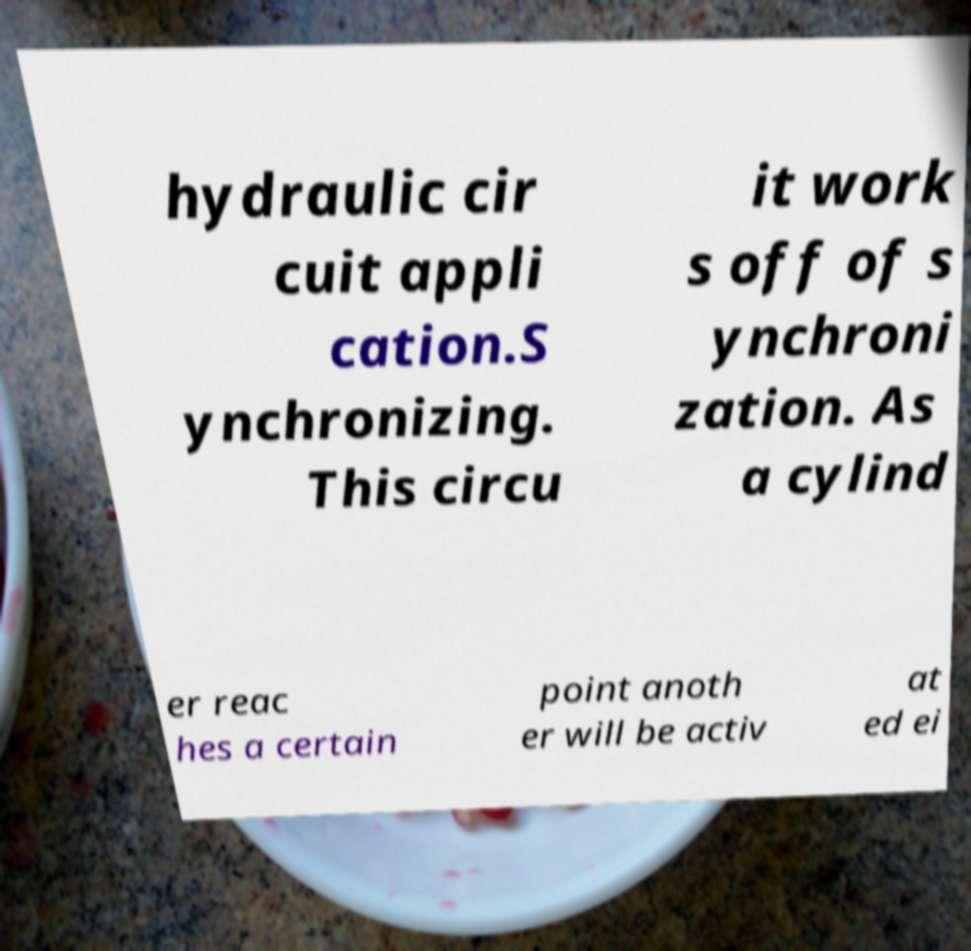I need the written content from this picture converted into text. Can you do that? hydraulic cir cuit appli cation.S ynchronizing. This circu it work s off of s ynchroni zation. As a cylind er reac hes a certain point anoth er will be activ at ed ei 